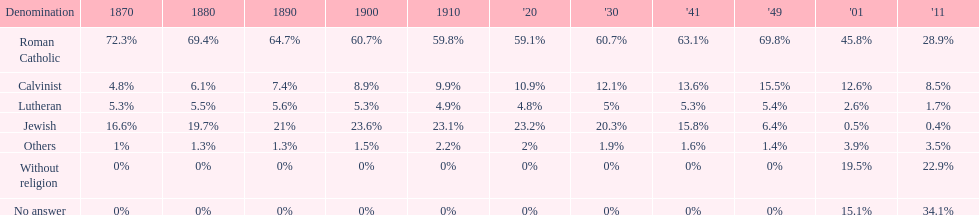Which religious denomination had a higher percentage in 1900, jewish or roman catholic? Roman Catholic. 